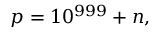<formula> <loc_0><loc_0><loc_500><loc_500>p = 1 0 ^ { 9 9 9 } + n ,</formula> 